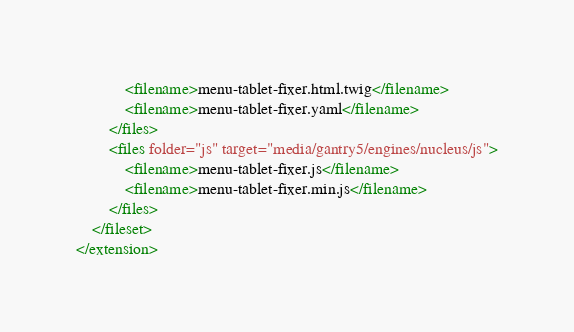<code> <loc_0><loc_0><loc_500><loc_500><_XML_>            <filename>menu-tablet-fixer.html.twig</filename>
            <filename>menu-tablet-fixer.yaml</filename>
        </files>
        <files folder="js" target="media/gantry5/engines/nucleus/js">
            <filename>menu-tablet-fixer.js</filename>
            <filename>menu-tablet-fixer.min.js</filename>
        </files>
    </fileset>
</extension></code> 